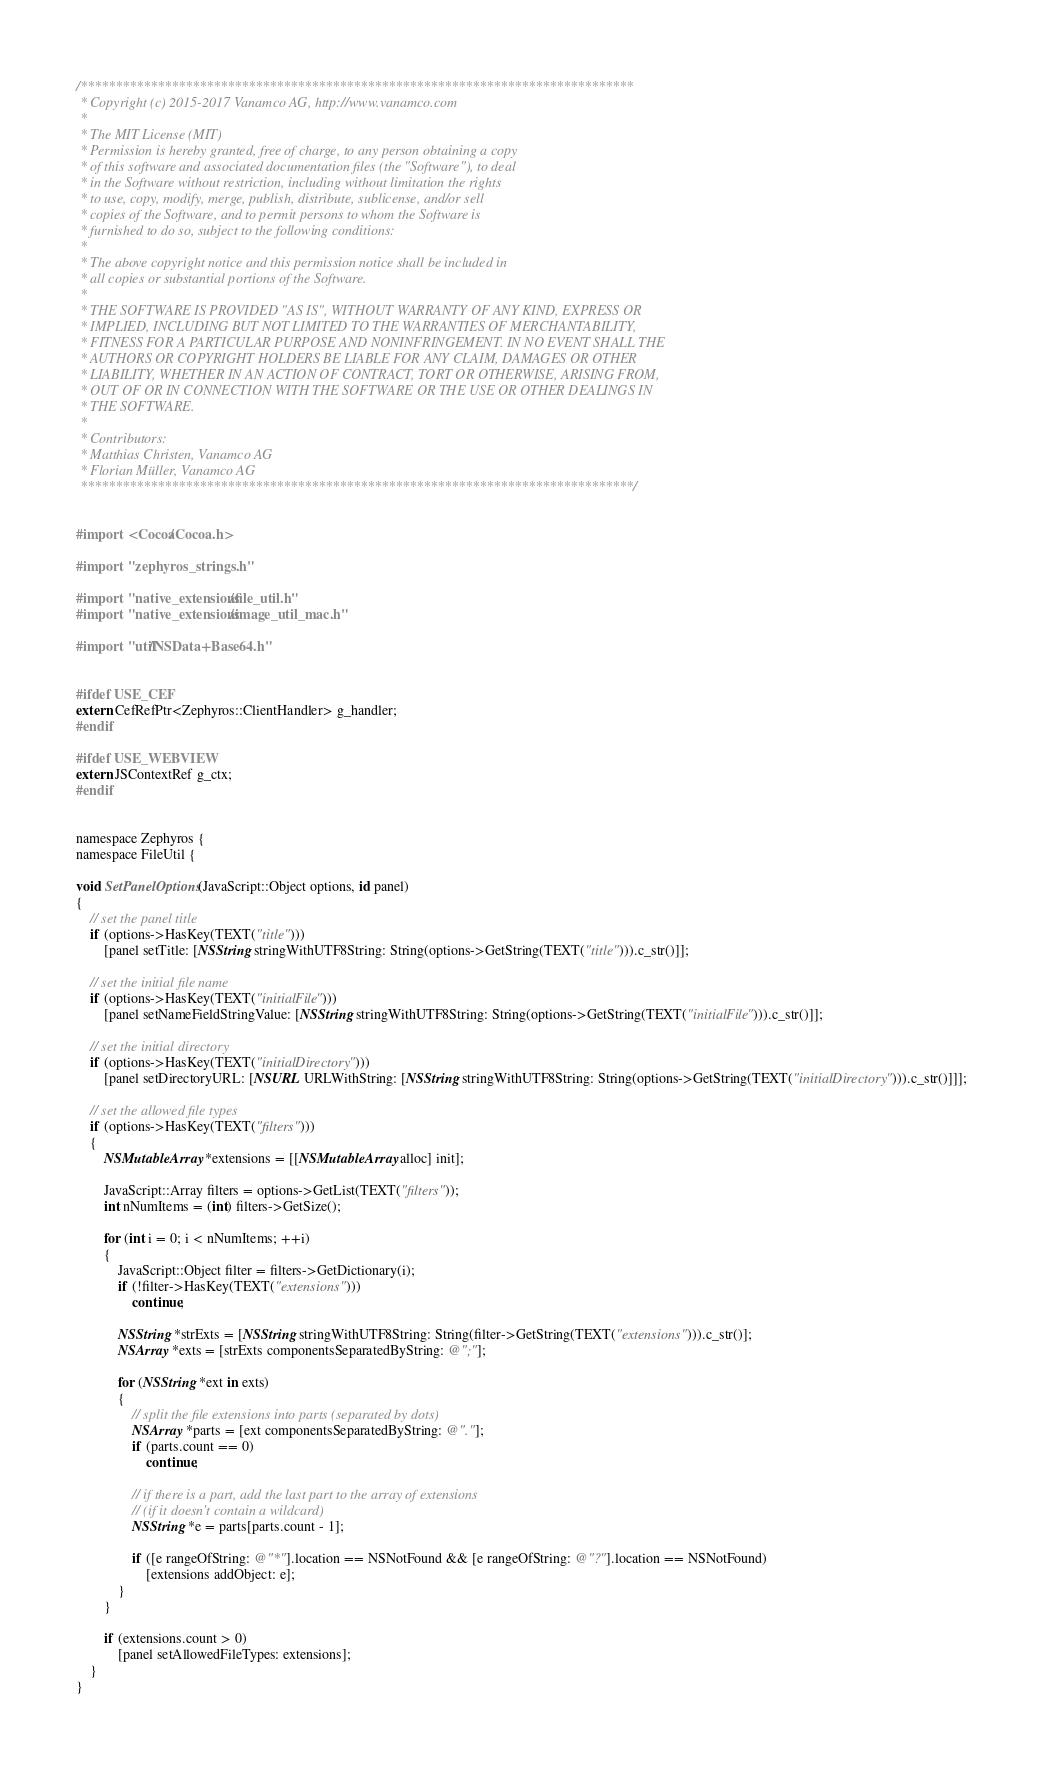Convert code to text. <code><loc_0><loc_0><loc_500><loc_500><_ObjectiveC_>/*******************************************************************************
 * Copyright (c) 2015-2017 Vanamco AG, http://www.vanamco.com
 *
 * The MIT License (MIT)
 * Permission is hereby granted, free of charge, to any person obtaining a copy
 * of this software and associated documentation files (the "Software"), to deal
 * in the Software without restriction, including without limitation the rights
 * to use, copy, modify, merge, publish, distribute, sublicense, and/or sell
 * copies of the Software, and to permit persons to whom the Software is
 * furnished to do so, subject to the following conditions:
 *
 * The above copyright notice and this permission notice shall be included in
 * all copies or substantial portions of the Software.
 *
 * THE SOFTWARE IS PROVIDED "AS IS", WITHOUT WARRANTY OF ANY KIND, EXPRESS OR
 * IMPLIED, INCLUDING BUT NOT LIMITED TO THE WARRANTIES OF MERCHANTABILITY,
 * FITNESS FOR A PARTICULAR PURPOSE AND NONINFRINGEMENT. IN NO EVENT SHALL THE
 * AUTHORS OR COPYRIGHT HOLDERS BE LIABLE FOR ANY CLAIM, DAMAGES OR OTHER
 * LIABILITY, WHETHER IN AN ACTION OF CONTRACT, TORT OR OTHERWISE, ARISING FROM,
 * OUT OF OR IN CONNECTION WITH THE SOFTWARE OR THE USE OR OTHER DEALINGS IN
 * THE SOFTWARE.
 *
 * Contributors:
 * Matthias Christen, Vanamco AG
 * Florian Müller, Vanamco AG
 *******************************************************************************/


#import <Cocoa/Cocoa.h>

#import "zephyros_strings.h"

#import "native_extensions/file_util.h"
#import "native_extensions/image_util_mac.h"

#import "util/NSData+Base64.h"


#ifdef USE_CEF
extern CefRefPtr<Zephyros::ClientHandler> g_handler;
#endif

#ifdef USE_WEBVIEW
extern JSContextRef g_ctx;
#endif


namespace Zephyros {
namespace FileUtil {

void SetPanelOptions(JavaScript::Object options, id panel)
{
    // set the panel title
    if (options->HasKey(TEXT("title")))
        [panel setTitle: [NSString stringWithUTF8String: String(options->GetString(TEXT("title"))).c_str()]];
    
    // set the initial file name
    if (options->HasKey(TEXT("initialFile")))
        [panel setNameFieldStringValue: [NSString stringWithUTF8String: String(options->GetString(TEXT("initialFile"))).c_str()]];
    
    // set the initial directory
    if (options->HasKey(TEXT("initialDirectory")))
        [panel setDirectoryURL: [NSURL URLWithString: [NSString stringWithUTF8String: String(options->GetString(TEXT("initialDirectory"))).c_str()]]];

    // set the allowed file types
    if (options->HasKey(TEXT("filters")))
    {
        NSMutableArray *extensions = [[NSMutableArray alloc] init];
        
        JavaScript::Array filters = options->GetList(TEXT("filters"));
        int nNumItems = (int) filters->GetSize();
        
        for (int i = 0; i < nNumItems; ++i)
        {
            JavaScript::Object filter = filters->GetDictionary(i);
            if (!filter->HasKey(TEXT("extensions")))
                continue;

            NSString *strExts = [NSString stringWithUTF8String: String(filter->GetString(TEXT("extensions"))).c_str()];
            NSArray *exts = [strExts componentsSeparatedByString: @";"];

            for (NSString *ext in exts)
            {
                // split the file extensions into parts (separated by dots)
                NSArray *parts = [ext componentsSeparatedByString: @"."];
                if (parts.count == 0)
                    continue;

                // if there is a part, add the last part to the array of extensions
                // (if it doesn't contain a wildcard)
                NSString *e = parts[parts.count - 1];

                if ([e rangeOfString: @"*"].location == NSNotFound && [e rangeOfString: @"?"].location == NSNotFound)
                    [extensions addObject: e];
            }
        }
        
        if (extensions.count > 0)
            [panel setAllowedFileTypes: extensions];
    }
}
</code> 